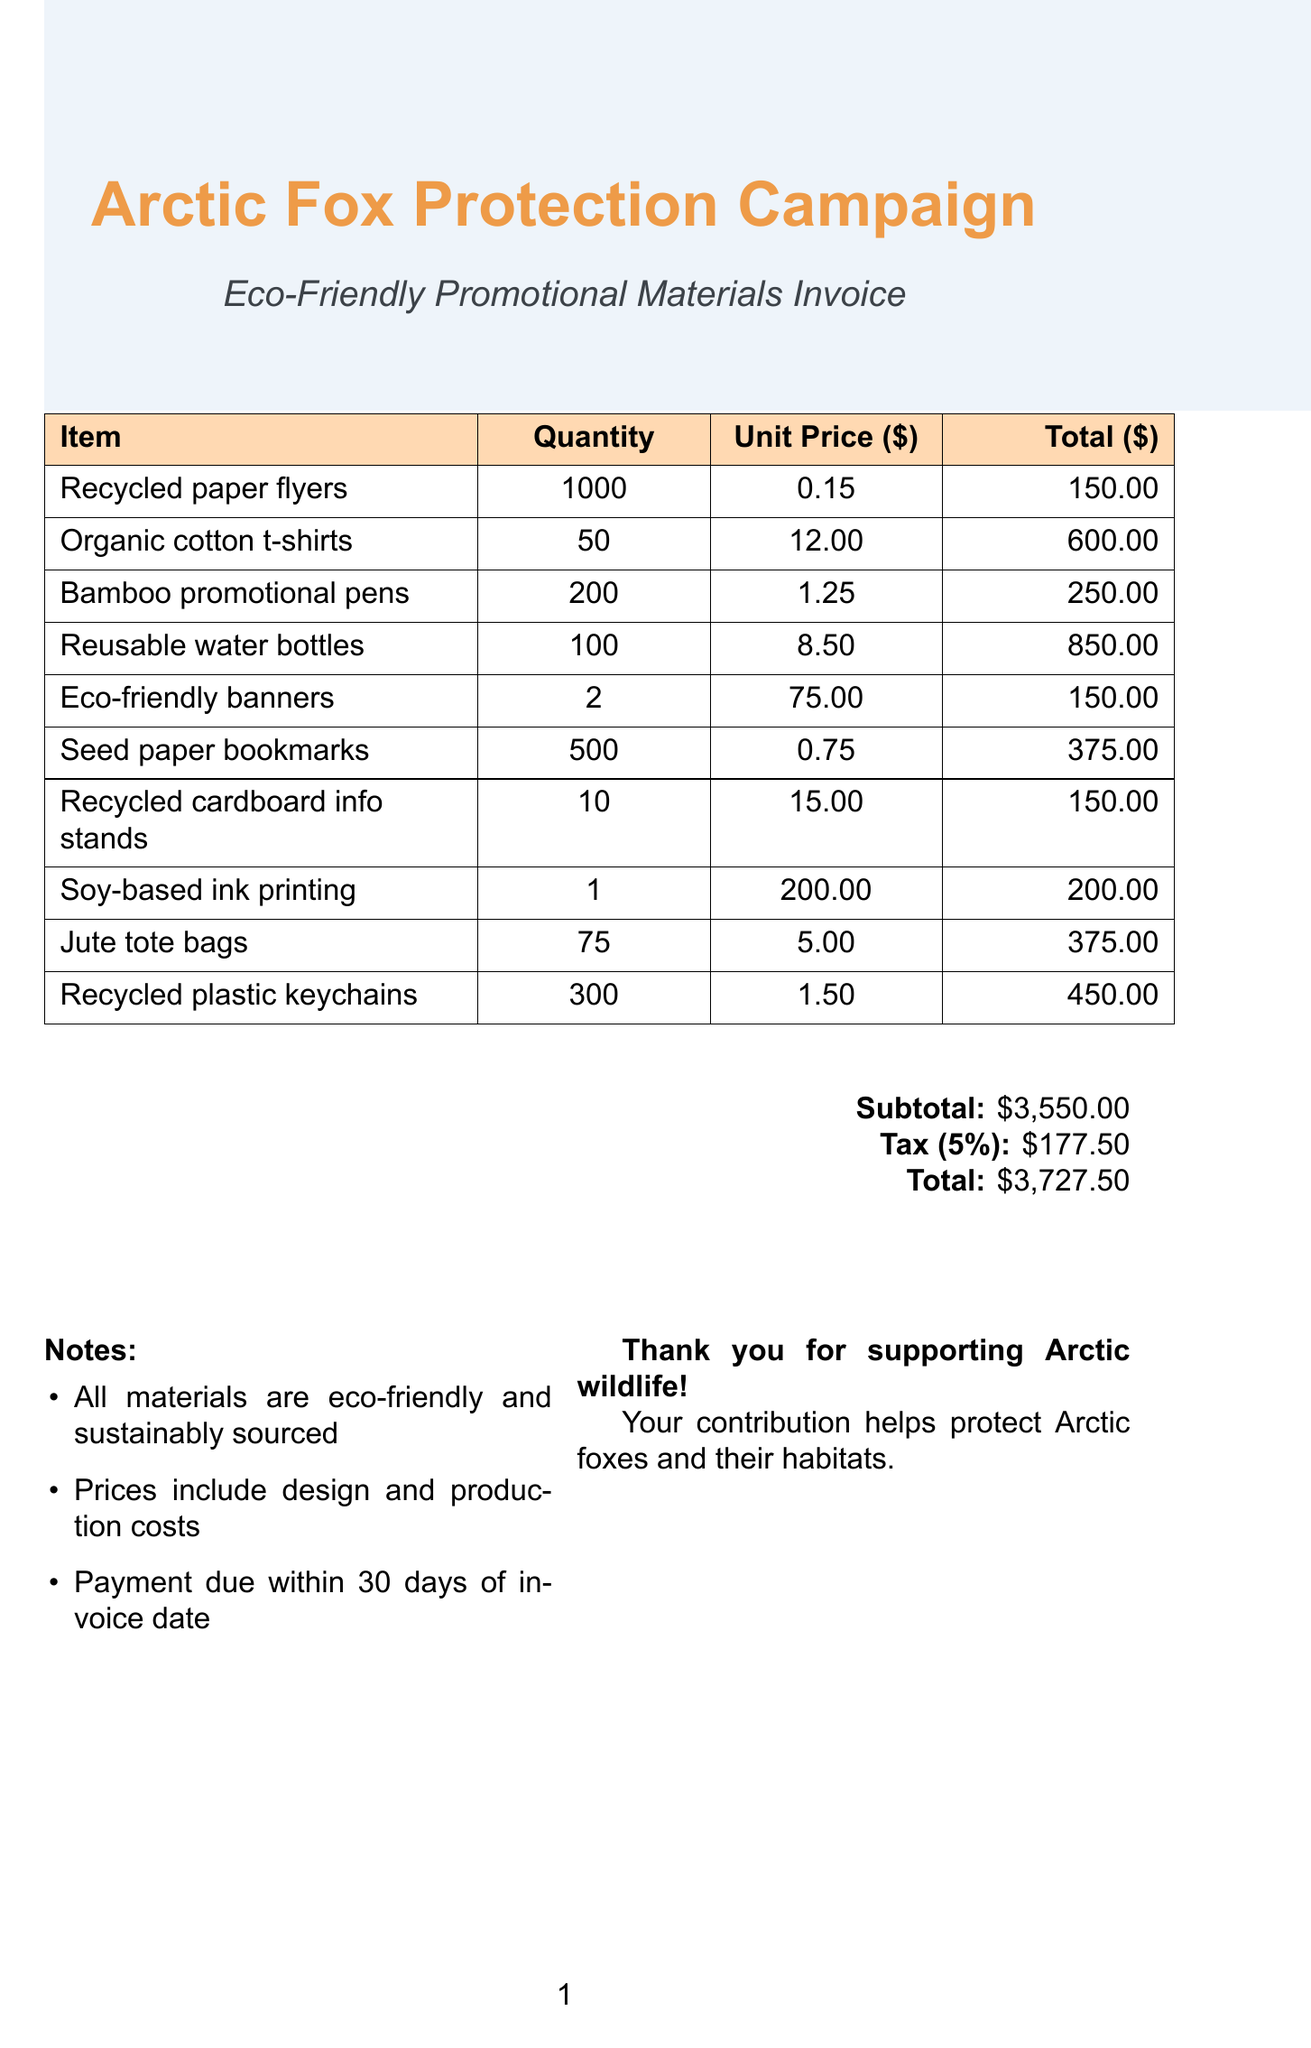what is the total amount of the invoice? The total amount is the final sum indicated in the invoice document, which includes the subtotal and tax.
Answer: $3727.50 how many organic cotton t-shirts were ordered? The quantity of organic cotton t-shirts is specified in the itemized list of products.
Answer: 50 what is the unit price of recycled paper flyers? The unit price of recycled paper flyers is given as part of the item description in the invoice.
Answer: $0.15 what type of ink was used for printing? The invoice specifies that soy-based ink printing was utilized for the promotional materials.
Answer: Soy-based ink how many seed paper bookmarks were ordered? The quantity of seed paper bookmarks is listed in the itemized section of the invoice.
Answer: 500 what is the subtotal before tax? The subtotal is the sum of all item totals before adding tax, and it is provided in the invoice.
Answer: $3550.00 how many eco-friendly banners were purchased? The quantity of eco-friendly banners is included in the itemized list within the document.
Answer: 2 what does the note say about payment? The notes section indicates specific payment terms related to the invoice.
Answer: Payment due within 30 days of invoice date which item has the highest total cost? The total cost of each item is provided, and reasoning over these totals indicates which is the highest.
Answer: Reusable water bottles what is the theme of the promotional materials? The overall theme is explicitly stated in the title and items of the invoice.
Answer: Arctic Fox Protection 